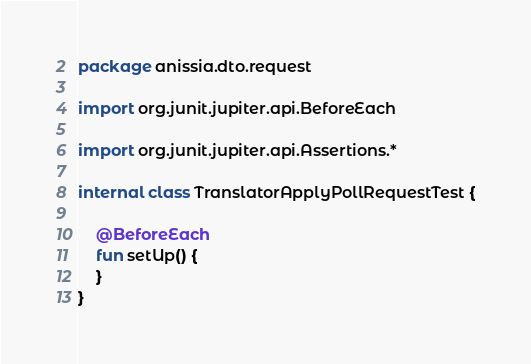<code> <loc_0><loc_0><loc_500><loc_500><_Kotlin_>package anissia.dto.request

import org.junit.jupiter.api.BeforeEach

import org.junit.jupiter.api.Assertions.*

internal class TranslatorApplyPollRequestTest {

    @BeforeEach
    fun setUp() {
    }
}</code> 